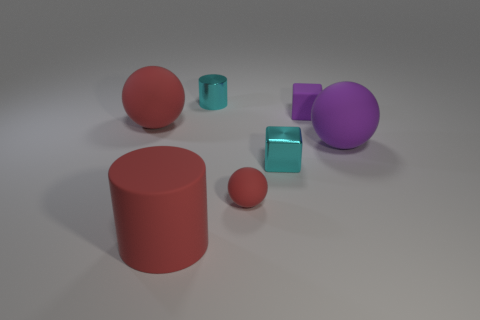There is a cube that is the same color as the small metallic cylinder; what is its size?
Make the answer very short. Small. What number of other objects are there of the same shape as the large purple object?
Your response must be concise. 2. The other shiny object that is the same shape as the small purple thing is what size?
Your answer should be compact. Small. Are there any tiny yellow metallic cubes?
Give a very brief answer. No. There is a matte block; is it the same color as the big ball that is on the right side of the large matte cylinder?
Your answer should be compact. Yes. How big is the rubber cylinder in front of the big sphere that is right of the tiny metal cylinder left of the rubber cube?
Ensure brevity in your answer.  Large. How many tiny objects are the same color as the metallic block?
Offer a very short reply. 1. How many things are either matte balls or small cyan metallic things in front of the large purple thing?
Ensure brevity in your answer.  4. What color is the tiny matte block?
Your answer should be very brief. Purple. The big sphere that is right of the tiny cyan block is what color?
Ensure brevity in your answer.  Purple. 